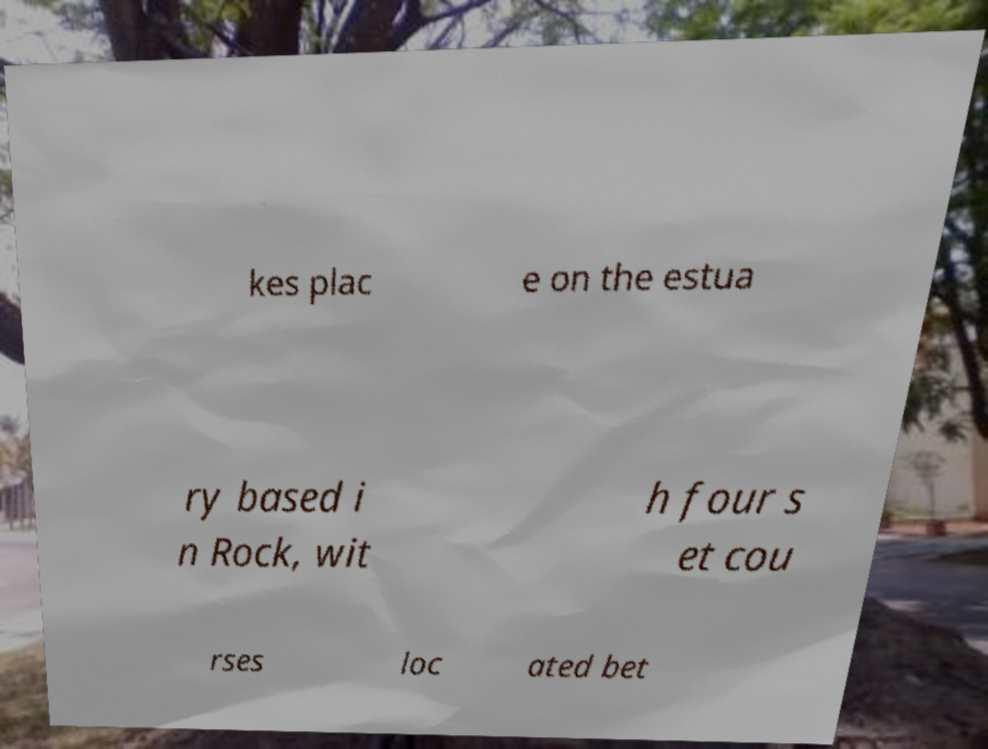Can you read and provide the text displayed in the image?This photo seems to have some interesting text. Can you extract and type it out for me? kes plac e on the estua ry based i n Rock, wit h four s et cou rses loc ated bet 